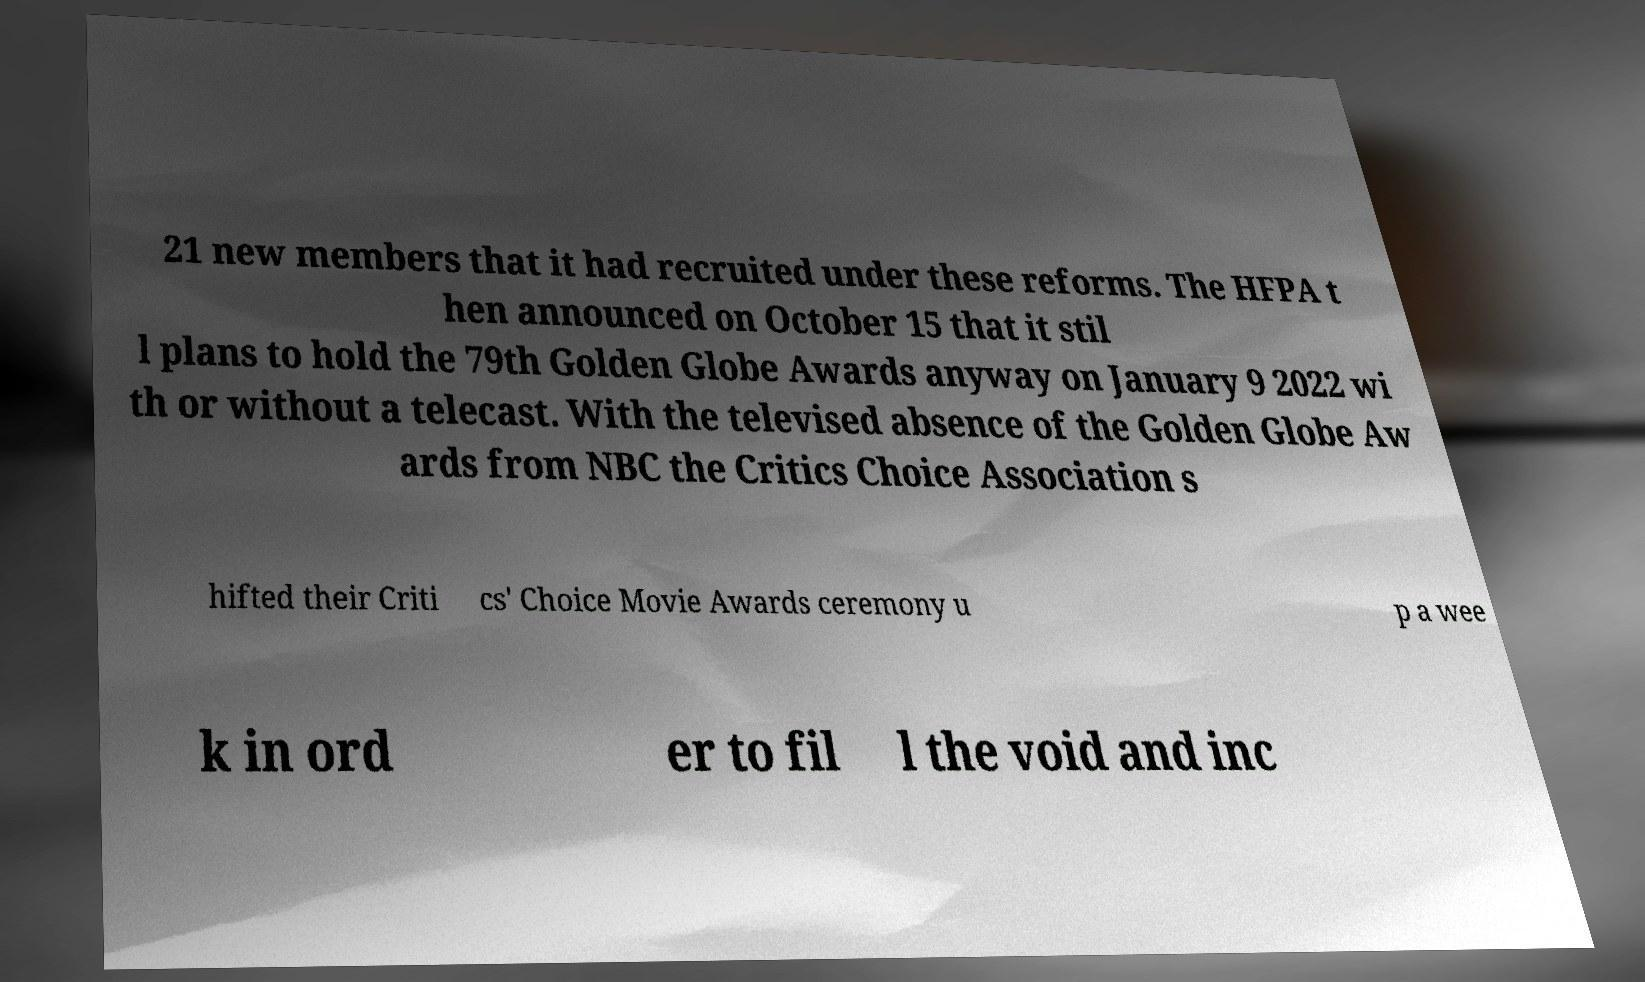Could you assist in decoding the text presented in this image and type it out clearly? 21 new members that it had recruited under these reforms. The HFPA t hen announced on October 15 that it stil l plans to hold the 79th Golden Globe Awards anyway on January 9 2022 wi th or without a telecast. With the televised absence of the Golden Globe Aw ards from NBC the Critics Choice Association s hifted their Criti cs' Choice Movie Awards ceremony u p a wee k in ord er to fil l the void and inc 